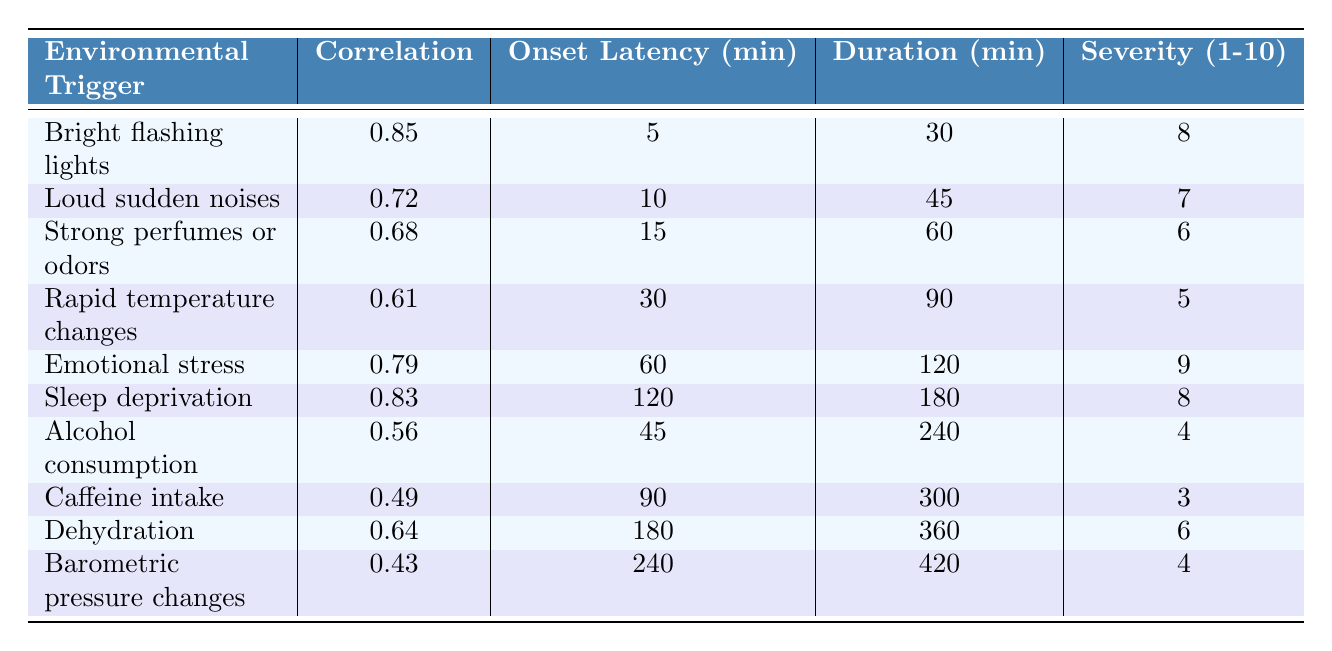What is the correlation score for "Emotional stress"? The table shows that the correlation score for "Emotional stress" is 0.79.
Answer: 0.79 What is the onset latency in minutes for "Bright flashing lights"? Referring to the table, "Bright flashing lights" has an onset latency of 5 minutes.
Answer: 5 Which trigger has the longest duration? The table indicates that "Barometric pressure changes" has the longest duration of 420 minutes.
Answer: 420 Is the severity scale for "Caffeine intake" higher than that for "Alcohol consumption"? The severity scale for "Caffeine intake" is 3, and for "Alcohol consumption" it is 4; therefore, the severity for "Alcohol consumption" is higher.
Answer: No What is the average correlation score of the triggers listed? To calculate the average correlation score, sum the correlations (0.85 + 0.72 + 0.68 + 0.61 + 0.79 + 0.83 + 0.56 + 0.49 + 0.64 + 0.43 = 6.86) and divide by the number of triggers (10), which gives an average of 0.686.
Answer: 0.686 Which trigger has the highest severity score? The table shows "Emotional stress" has the highest severity score at 9.
Answer: Emotional stress What is the total onset latency for "Sleep deprivation" and "Rapid temperature changes"? The onset latency for "Sleep deprivation" is 120 minutes and for "Rapid temperature changes" is 30 minutes. Adding these gives 120 + 30 = 150 minutes.
Answer: 150 If a person experiences "Dehydration," how long will it likely take for the altered state to onset, according to the table? According to the table, the onset latency for "Dehydration" is 180 minutes.
Answer: 180 How many triggers have a correlation score above 0.7? The triggers with a correlation score above 0.7 are "Bright flashing lights," "Loud sudden noises," "Emotional stress," and "Sleep deprivation," totaling 4 triggers.
Answer: 4 What is the difference in duration between "Sleep deprivation" and "Alcohol consumption"? "Sleep deprivation" lasts 180 minutes and "Alcohol consumption" lasts 240 minutes. The difference is 240 - 180 = 60 minutes.
Answer: 60 Which environmental trigger takes the longest to trigger an altered state? The table indicates that "Barometric pressure changes" takes the longest at 240 minutes to trigger an altered state.
Answer: Barometric pressure changes 